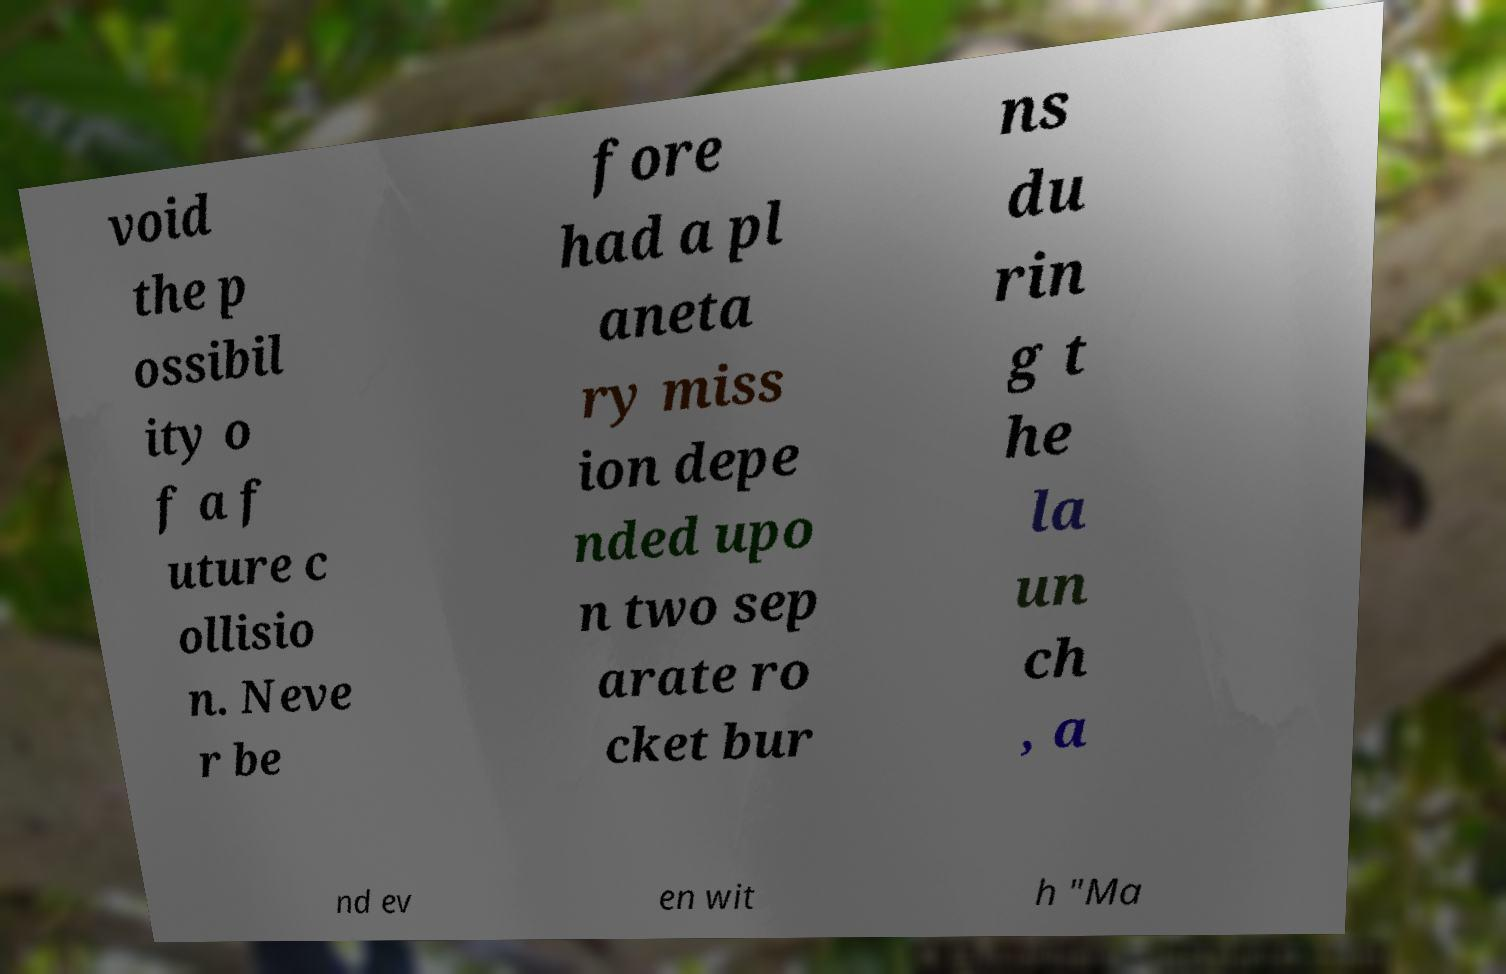I need the written content from this picture converted into text. Can you do that? void the p ossibil ity o f a f uture c ollisio n. Neve r be fore had a pl aneta ry miss ion depe nded upo n two sep arate ro cket bur ns du rin g t he la un ch , a nd ev en wit h "Ma 